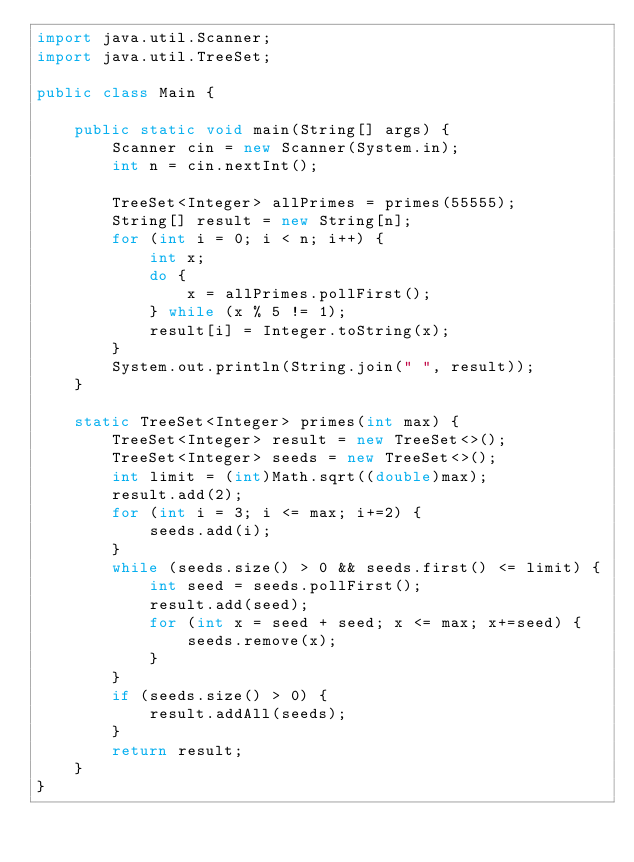Convert code to text. <code><loc_0><loc_0><loc_500><loc_500><_Java_>import java.util.Scanner;
import java.util.TreeSet;

public class Main {

    public static void main(String[] args) {
        Scanner cin = new Scanner(System.in);
        int n = cin.nextInt();

        TreeSet<Integer> allPrimes = primes(55555);
        String[] result = new String[n];
        for (int i = 0; i < n; i++) {
            int x;
            do {
                x = allPrimes.pollFirst();
            } while (x % 5 != 1);
            result[i] = Integer.toString(x);
        }
        System.out.println(String.join(" ", result));
    }

    static TreeSet<Integer> primes(int max) {
        TreeSet<Integer> result = new TreeSet<>();
        TreeSet<Integer> seeds = new TreeSet<>();
        int limit = (int)Math.sqrt((double)max);
        result.add(2);
        for (int i = 3; i <= max; i+=2) {
            seeds.add(i);
        }
        while (seeds.size() > 0 && seeds.first() <= limit) {
            int seed = seeds.pollFirst();
            result.add(seed);
            for (int x = seed + seed; x <= max; x+=seed) {
                seeds.remove(x);
            }
        }
        if (seeds.size() > 0) {
            result.addAll(seeds);
        }
        return result;
    }
}
</code> 